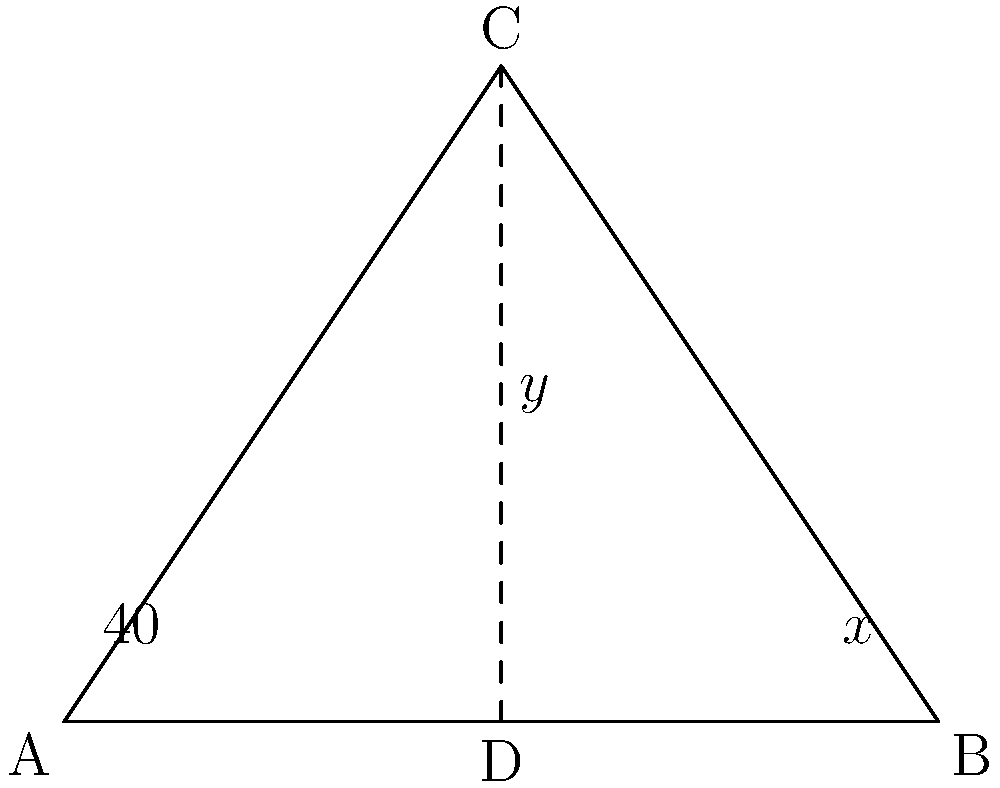In this Phulkari embroidery pattern, two intersecting lines form a triangle ABC. If angle BAD measures 40°, what is the value of $x + y$? Let's approach this step-by-step:

1) In triangle ABC, we can see that line AD bisects the triangle, creating two smaller triangles.

2) In triangle ADB:
   - We're given that $\angle BAD = 40°$
   - $\angle ADB = 90°$ (since AD is perpendicular to BC)
   - Therefore, $\angle ABD = 180° - 90° - 40° = 50°$ (sum of angles in a triangle is 180°)

3) Now, let's look at triangle BDC:
   - We know $\angle CBD = 50°$ (vertically opposite to $\angle ABD$)
   - $\angle BDC = 90°$ (same as $\angle ADB$)
   - Therefore, $\angle BCD = 180° - 90° - 50° = 40°$

4) We can now identify:
   - $x = \angle CBD = 50°$
   - $y = \angle BCD = 40°$

5) The question asks for $x + y$:
   $x + y = 50° + 40° = 90°$
Answer: $90°$ 